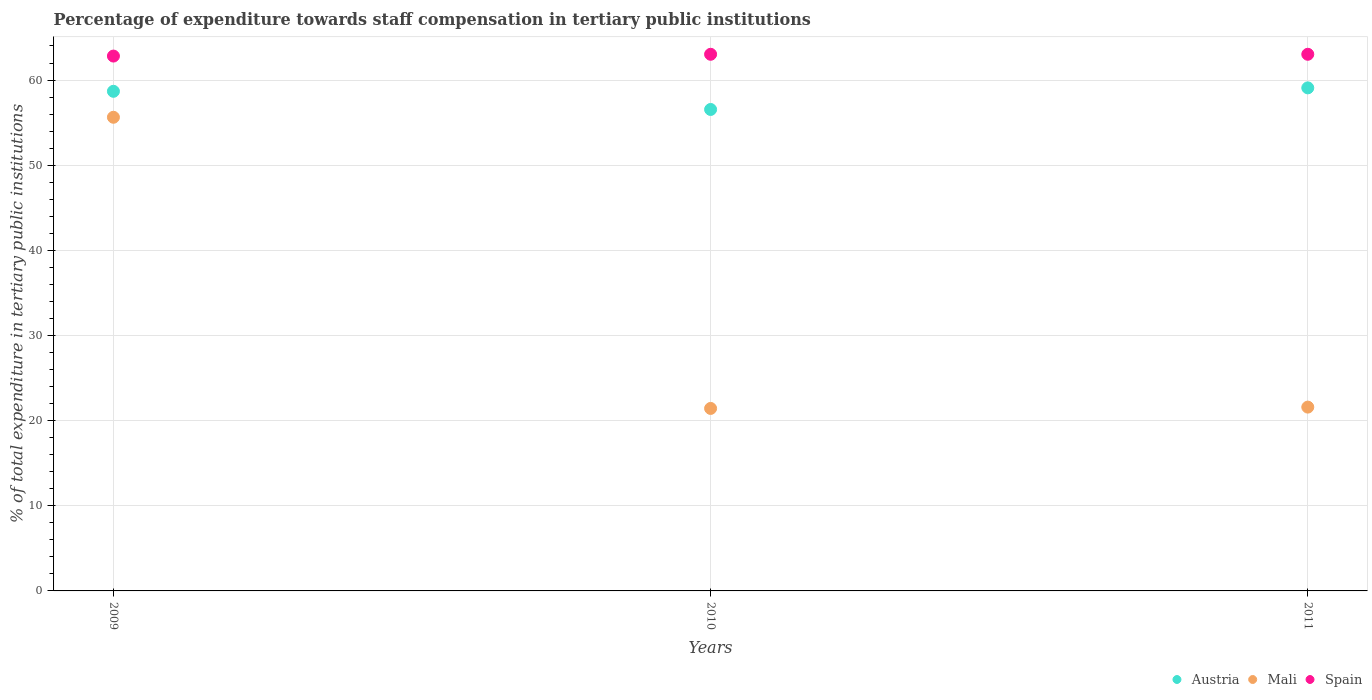What is the percentage of expenditure towards staff compensation in Spain in 2011?
Your answer should be very brief. 63.03. Across all years, what is the maximum percentage of expenditure towards staff compensation in Spain?
Provide a succinct answer. 63.03. Across all years, what is the minimum percentage of expenditure towards staff compensation in Mali?
Provide a short and direct response. 21.43. What is the total percentage of expenditure towards staff compensation in Spain in the graph?
Provide a short and direct response. 188.87. What is the difference between the percentage of expenditure towards staff compensation in Austria in 2009 and that in 2010?
Make the answer very short. 2.13. What is the difference between the percentage of expenditure towards staff compensation in Mali in 2011 and the percentage of expenditure towards staff compensation in Spain in 2009?
Give a very brief answer. -41.23. What is the average percentage of expenditure towards staff compensation in Spain per year?
Your answer should be very brief. 62.96. In the year 2011, what is the difference between the percentage of expenditure towards staff compensation in Austria and percentage of expenditure towards staff compensation in Mali?
Your response must be concise. 37.49. In how many years, is the percentage of expenditure towards staff compensation in Spain greater than 60 %?
Offer a terse response. 3. What is the ratio of the percentage of expenditure towards staff compensation in Austria in 2009 to that in 2011?
Provide a short and direct response. 0.99. Is the percentage of expenditure towards staff compensation in Mali in 2009 less than that in 2011?
Provide a succinct answer. No. Is the difference between the percentage of expenditure towards staff compensation in Austria in 2009 and 2011 greater than the difference between the percentage of expenditure towards staff compensation in Mali in 2009 and 2011?
Offer a terse response. No. What is the difference between the highest and the second highest percentage of expenditure towards staff compensation in Austria?
Offer a terse response. 0.4. What is the difference between the highest and the lowest percentage of expenditure towards staff compensation in Spain?
Your answer should be compact. 0.21. Is the sum of the percentage of expenditure towards staff compensation in Spain in 2009 and 2011 greater than the maximum percentage of expenditure towards staff compensation in Mali across all years?
Make the answer very short. Yes. Is it the case that in every year, the sum of the percentage of expenditure towards staff compensation in Mali and percentage of expenditure towards staff compensation in Spain  is greater than the percentage of expenditure towards staff compensation in Austria?
Your answer should be very brief. Yes. Is the percentage of expenditure towards staff compensation in Mali strictly greater than the percentage of expenditure towards staff compensation in Austria over the years?
Make the answer very short. No. Is the percentage of expenditure towards staff compensation in Spain strictly less than the percentage of expenditure towards staff compensation in Austria over the years?
Provide a short and direct response. No. What is the difference between two consecutive major ticks on the Y-axis?
Your answer should be compact. 10. How are the legend labels stacked?
Your answer should be very brief. Horizontal. What is the title of the graph?
Ensure brevity in your answer.  Percentage of expenditure towards staff compensation in tertiary public institutions. What is the label or title of the X-axis?
Provide a short and direct response. Years. What is the label or title of the Y-axis?
Provide a short and direct response. % of total expenditure in tertiary public institutions. What is the % of total expenditure in tertiary public institutions of Austria in 2009?
Your answer should be compact. 58.68. What is the % of total expenditure in tertiary public institutions in Mali in 2009?
Give a very brief answer. 55.63. What is the % of total expenditure in tertiary public institutions of Spain in 2009?
Offer a terse response. 62.82. What is the % of total expenditure in tertiary public institutions in Austria in 2010?
Ensure brevity in your answer.  56.54. What is the % of total expenditure in tertiary public institutions of Mali in 2010?
Make the answer very short. 21.43. What is the % of total expenditure in tertiary public institutions in Spain in 2010?
Give a very brief answer. 63.03. What is the % of total expenditure in tertiary public institutions in Austria in 2011?
Keep it short and to the point. 59.08. What is the % of total expenditure in tertiary public institutions of Mali in 2011?
Make the answer very short. 21.59. What is the % of total expenditure in tertiary public institutions of Spain in 2011?
Offer a very short reply. 63.03. Across all years, what is the maximum % of total expenditure in tertiary public institutions in Austria?
Keep it short and to the point. 59.08. Across all years, what is the maximum % of total expenditure in tertiary public institutions of Mali?
Make the answer very short. 55.63. Across all years, what is the maximum % of total expenditure in tertiary public institutions of Spain?
Your response must be concise. 63.03. Across all years, what is the minimum % of total expenditure in tertiary public institutions in Austria?
Provide a succinct answer. 56.54. Across all years, what is the minimum % of total expenditure in tertiary public institutions in Mali?
Provide a short and direct response. 21.43. Across all years, what is the minimum % of total expenditure in tertiary public institutions of Spain?
Your answer should be very brief. 62.82. What is the total % of total expenditure in tertiary public institutions in Austria in the graph?
Ensure brevity in your answer.  174.3. What is the total % of total expenditure in tertiary public institutions of Mali in the graph?
Provide a short and direct response. 98.65. What is the total % of total expenditure in tertiary public institutions in Spain in the graph?
Offer a very short reply. 188.87. What is the difference between the % of total expenditure in tertiary public institutions of Austria in 2009 and that in 2010?
Keep it short and to the point. 2.13. What is the difference between the % of total expenditure in tertiary public institutions of Mali in 2009 and that in 2010?
Provide a short and direct response. 34.2. What is the difference between the % of total expenditure in tertiary public institutions in Spain in 2009 and that in 2010?
Provide a short and direct response. -0.21. What is the difference between the % of total expenditure in tertiary public institutions in Austria in 2009 and that in 2011?
Keep it short and to the point. -0.4. What is the difference between the % of total expenditure in tertiary public institutions in Mali in 2009 and that in 2011?
Offer a very short reply. 34.04. What is the difference between the % of total expenditure in tertiary public institutions in Spain in 2009 and that in 2011?
Your response must be concise. -0.21. What is the difference between the % of total expenditure in tertiary public institutions in Austria in 2010 and that in 2011?
Provide a succinct answer. -2.54. What is the difference between the % of total expenditure in tertiary public institutions in Mali in 2010 and that in 2011?
Provide a succinct answer. -0.16. What is the difference between the % of total expenditure in tertiary public institutions of Austria in 2009 and the % of total expenditure in tertiary public institutions of Mali in 2010?
Your answer should be very brief. 37.24. What is the difference between the % of total expenditure in tertiary public institutions in Austria in 2009 and the % of total expenditure in tertiary public institutions in Spain in 2010?
Make the answer very short. -4.35. What is the difference between the % of total expenditure in tertiary public institutions of Mali in 2009 and the % of total expenditure in tertiary public institutions of Spain in 2010?
Offer a terse response. -7.4. What is the difference between the % of total expenditure in tertiary public institutions in Austria in 2009 and the % of total expenditure in tertiary public institutions in Mali in 2011?
Your response must be concise. 37.09. What is the difference between the % of total expenditure in tertiary public institutions in Austria in 2009 and the % of total expenditure in tertiary public institutions in Spain in 2011?
Your answer should be very brief. -4.35. What is the difference between the % of total expenditure in tertiary public institutions in Mali in 2009 and the % of total expenditure in tertiary public institutions in Spain in 2011?
Offer a terse response. -7.4. What is the difference between the % of total expenditure in tertiary public institutions of Austria in 2010 and the % of total expenditure in tertiary public institutions of Mali in 2011?
Make the answer very short. 34.96. What is the difference between the % of total expenditure in tertiary public institutions of Austria in 2010 and the % of total expenditure in tertiary public institutions of Spain in 2011?
Keep it short and to the point. -6.48. What is the difference between the % of total expenditure in tertiary public institutions in Mali in 2010 and the % of total expenditure in tertiary public institutions in Spain in 2011?
Provide a succinct answer. -41.59. What is the average % of total expenditure in tertiary public institutions of Austria per year?
Offer a very short reply. 58.1. What is the average % of total expenditure in tertiary public institutions of Mali per year?
Offer a terse response. 32.88. What is the average % of total expenditure in tertiary public institutions of Spain per year?
Your answer should be compact. 62.96. In the year 2009, what is the difference between the % of total expenditure in tertiary public institutions of Austria and % of total expenditure in tertiary public institutions of Mali?
Offer a very short reply. 3.05. In the year 2009, what is the difference between the % of total expenditure in tertiary public institutions in Austria and % of total expenditure in tertiary public institutions in Spain?
Offer a terse response. -4.14. In the year 2009, what is the difference between the % of total expenditure in tertiary public institutions in Mali and % of total expenditure in tertiary public institutions in Spain?
Provide a succinct answer. -7.19. In the year 2010, what is the difference between the % of total expenditure in tertiary public institutions of Austria and % of total expenditure in tertiary public institutions of Mali?
Provide a succinct answer. 35.11. In the year 2010, what is the difference between the % of total expenditure in tertiary public institutions in Austria and % of total expenditure in tertiary public institutions in Spain?
Your answer should be compact. -6.48. In the year 2010, what is the difference between the % of total expenditure in tertiary public institutions in Mali and % of total expenditure in tertiary public institutions in Spain?
Make the answer very short. -41.59. In the year 2011, what is the difference between the % of total expenditure in tertiary public institutions in Austria and % of total expenditure in tertiary public institutions in Mali?
Give a very brief answer. 37.49. In the year 2011, what is the difference between the % of total expenditure in tertiary public institutions of Austria and % of total expenditure in tertiary public institutions of Spain?
Make the answer very short. -3.94. In the year 2011, what is the difference between the % of total expenditure in tertiary public institutions of Mali and % of total expenditure in tertiary public institutions of Spain?
Your answer should be compact. -41.44. What is the ratio of the % of total expenditure in tertiary public institutions in Austria in 2009 to that in 2010?
Offer a very short reply. 1.04. What is the ratio of the % of total expenditure in tertiary public institutions of Mali in 2009 to that in 2010?
Offer a very short reply. 2.6. What is the ratio of the % of total expenditure in tertiary public institutions of Spain in 2009 to that in 2010?
Provide a short and direct response. 1. What is the ratio of the % of total expenditure in tertiary public institutions in Austria in 2009 to that in 2011?
Make the answer very short. 0.99. What is the ratio of the % of total expenditure in tertiary public institutions in Mali in 2009 to that in 2011?
Your response must be concise. 2.58. What is the ratio of the % of total expenditure in tertiary public institutions of Austria in 2010 to that in 2011?
Your answer should be very brief. 0.96. What is the ratio of the % of total expenditure in tertiary public institutions in Spain in 2010 to that in 2011?
Your answer should be very brief. 1. What is the difference between the highest and the second highest % of total expenditure in tertiary public institutions in Austria?
Keep it short and to the point. 0.4. What is the difference between the highest and the second highest % of total expenditure in tertiary public institutions of Mali?
Provide a short and direct response. 34.04. What is the difference between the highest and the second highest % of total expenditure in tertiary public institutions of Spain?
Make the answer very short. 0. What is the difference between the highest and the lowest % of total expenditure in tertiary public institutions in Austria?
Provide a succinct answer. 2.54. What is the difference between the highest and the lowest % of total expenditure in tertiary public institutions of Mali?
Ensure brevity in your answer.  34.2. What is the difference between the highest and the lowest % of total expenditure in tertiary public institutions of Spain?
Make the answer very short. 0.21. 